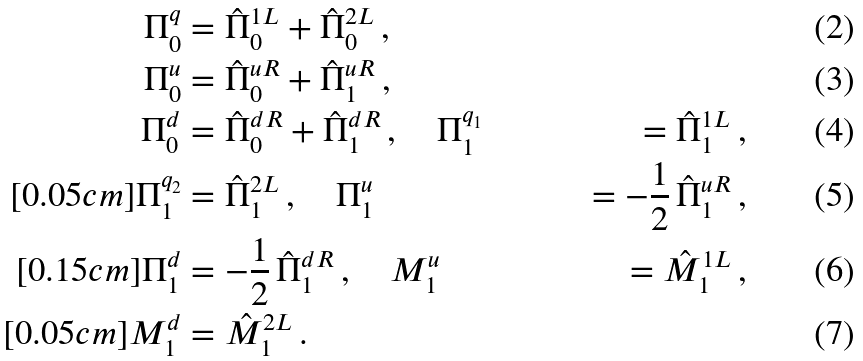Convert formula to latex. <formula><loc_0><loc_0><loc_500><loc_500>\Pi _ { 0 } ^ { q } & = \hat { \Pi } _ { 0 } ^ { 1 L } + \hat { \Pi } _ { 0 } ^ { 2 L } \, , \\ \Pi _ { 0 } ^ { u } & = \hat { \Pi } _ { 0 } ^ { u R } + \hat { \Pi } _ { 1 } ^ { u R } \, , \\ \Pi _ { 0 } ^ { d } & = \hat { \Pi } _ { 0 } ^ { d R } + \hat { \Pi } _ { 1 } ^ { d R } \, , \quad \Pi _ { 1 } ^ { q _ { 1 } } & = \hat { \Pi } _ { 1 } ^ { 1 L } \, , \\ [ 0 . 0 5 c m ] \Pi _ { 1 } ^ { q _ { 2 } } & = \hat { \Pi } _ { 1 } ^ { 2 L } \, , \quad \Pi _ { 1 } ^ { u } & = - \frac { 1 } { 2 } \, \hat { \Pi } _ { 1 } ^ { u R } \, , \\ [ 0 . 1 5 c m ] \Pi _ { 1 } ^ { d } & = - \frac { 1 } { 2 } \, \hat { \Pi } _ { 1 } ^ { d R } \, , \quad M _ { 1 } ^ { u } & = \hat { M } _ { 1 } ^ { 1 L } \, , \\ [ 0 . 0 5 c m ] M _ { 1 } ^ { d } & = \hat { M } _ { 1 } ^ { 2 L } \, .</formula> 